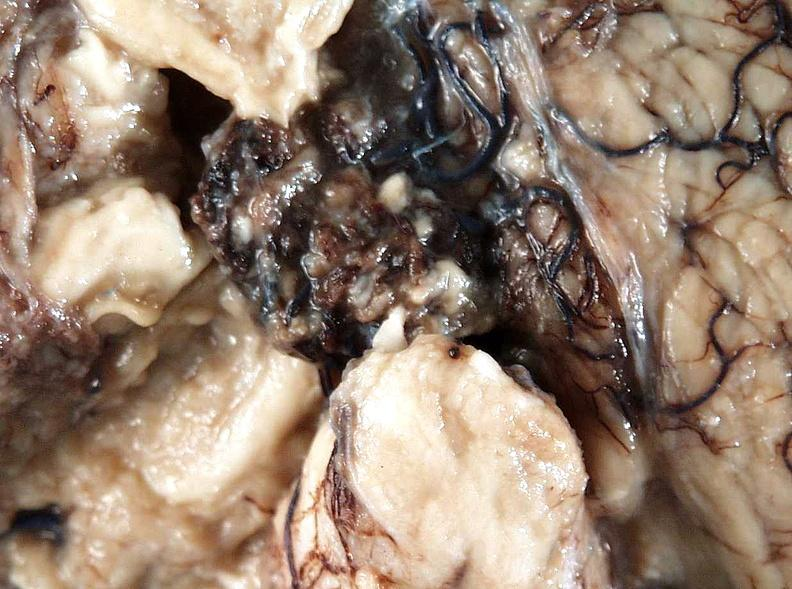what is present?
Answer the question using a single word or phrase. Nervous 